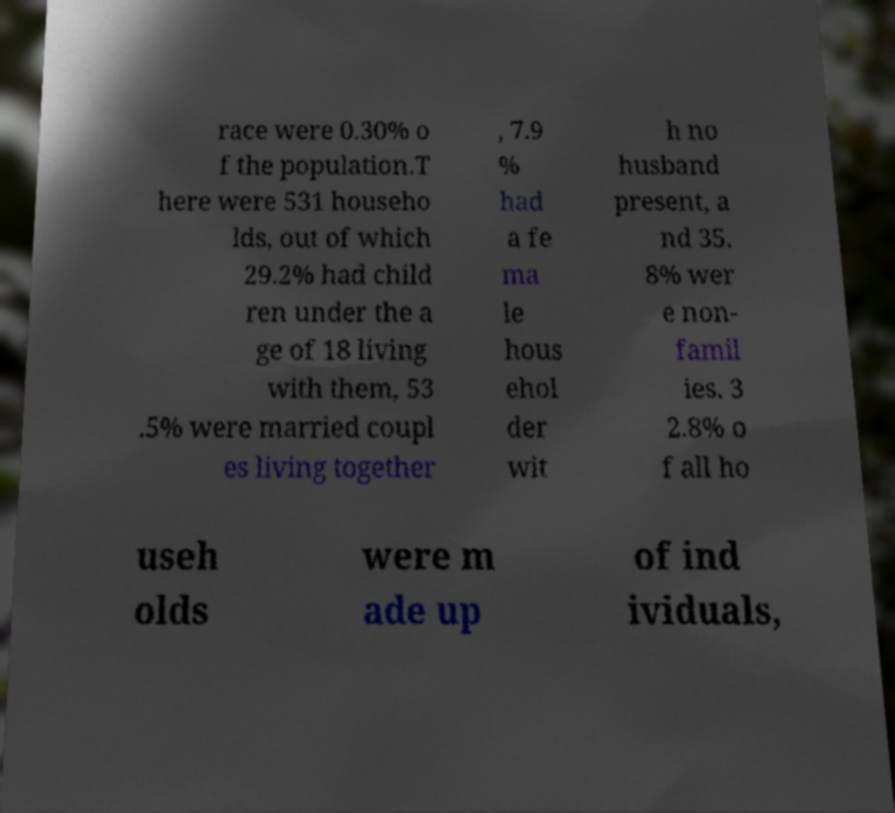I need the written content from this picture converted into text. Can you do that? race were 0.30% o f the population.T here were 531 househo lds, out of which 29.2% had child ren under the a ge of 18 living with them, 53 .5% were married coupl es living together , 7.9 % had a fe ma le hous ehol der wit h no husband present, a nd 35. 8% wer e non- famil ies. 3 2.8% o f all ho useh olds were m ade up of ind ividuals, 